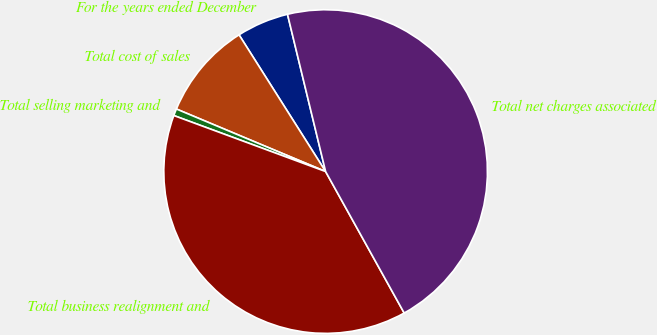Convert chart to OTSL. <chart><loc_0><loc_0><loc_500><loc_500><pie_chart><fcel>For the years ended December<fcel>Total cost of sales<fcel>Total selling marketing and<fcel>Total business realignment and<fcel>Total net charges associated<nl><fcel>5.2%<fcel>9.7%<fcel>0.69%<fcel>38.7%<fcel>45.72%<nl></chart> 